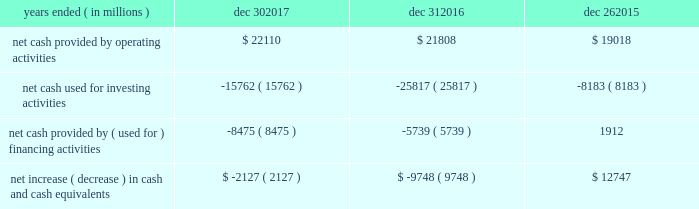In summary , our cash flows for each period were as follows : years ended ( in millions ) dec 30 , dec 31 , dec 26 .
Operating activities cash provided by operating activities is net income adjusted for certain non-cash items and changes in assets and liabilities .
For 2017 compared to 2016 , the $ 302 million increase in cash provided by operating activities was due to changes to working capital partially offset by adjustments for non-cash items and lower net income .
Tax reform did not have an impact on our 2017 cash provided by operating activities .
The increase in cash provided by operating activities was driven by increased income before taxes and $ 1.0 billion receipts of customer deposits .
These increases were partially offset by increased inventory and accounts receivable .
Income taxes paid , net of refunds , in 2017 compared to 2016 were $ 2.9 billion higher due to higher income before taxes , taxable gains on sales of asml , and taxes on the isecg divestiture .
We expect approximately $ 2.0 billion of additional customer deposits in 2018 .
For 2016 compared to 2015 , the $ 2.8 billion increase in cash provided by operating activities was due to adjustments for non-cash items and changes in working capital , partially offset by lower net income .
The adjustments for non-cash items were higher in 2016 primarily due to restructuring and other charges and the change in deferred taxes , partially offset by lower depreciation .
Investing activities investing cash flows consist primarily of capital expenditures ; investment purchases , sales , maturities , and disposals ; and proceeds from divestitures and cash used for acquisitions .
Our capital expenditures were $ 11.8 billion in 2017 ( $ 9.6 billion in 2016 and $ 7.3 billion in 2015 ) .
The decrease in cash used for investing activities in 2017 compared to 2016 was primarily due to higher net activity of available-for sale-investments in 2017 , proceeds from our divestiture of isecg in 2017 , and higher maturities and sales of trading assets in 2017 .
This activity was partially offset by higher capital expenditures in 2017 .
The increase in cash used for investing activities in 2016 compared to 2015 was primarily due to our completed acquisition of altera , net purchases of trading assets in 2016 compared to net sales of trading assets in 2015 , and higher capital expenditures in 2016 .
This increase was partially offset by lower investments in non-marketable equity investments .
Financing activities financing cash flows consist primarily of repurchases of common stock , payment of dividends to stockholders , issuance and repayment of short-term and long-term debt , and proceeds from the sale of shares of common stock through employee equity incentive plans .
The increase in cash used for financing activities in 2017 compared to 2016 was primarily due to net long-term debt activity , which was a use of cash in 2017 compared to a source of cash in 2016 .
During 2017 , we repurchased $ 3.6 billion of common stock under our authorized common stock repurchase program , compared to $ 2.6 billion in 2016 .
As of december 30 , 2017 , $ 13.2 billion remained available for repurchasing common stock under the existing repurchase authorization limit .
We base our level of common stock repurchases on internal cash management decisions , and this level may fluctuate .
Proceeds from the sale of common stock through employee equity incentive plans totaled $ 770 million in 2017 compared to $ 1.1 billion in 2016 .
Our total dividend payments were $ 5.1 billion in 2017 compared to $ 4.9 billion in 2016 .
We have paid a cash dividend in each of the past 101 quarters .
In january 2018 , our board of directors approved an increase to our cash dividend to $ 1.20 per share on an annual basis .
The board has declared a quarterly cash dividend of $ 0.30 per share of common stock for q1 2018 .
The dividend is payable on march 1 , 2018 to stockholders of record on february 7 , 2018 .
Cash was used for financing activities in 2016 compared to cash provided by financing activities in 2015 , primarily due to fewer debt issuances and the repayment of debt in 2016 .
This activity was partially offset by repayment of commercial paper in 2015 and fewer common stock repurchases in 2016 .
Md&a - results of operations consolidated results and analysis 37 .
What was the percentage change in net cash provided by operating activities from 2016 to 2017? 
Computations: ((22110 - 21808) / 21808)
Answer: 0.01385. 